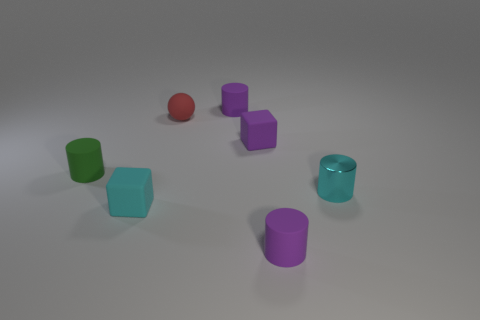Subtract all purple cylinders. How many were subtracted if there are1purple cylinders left? 1 Add 1 tiny cyan rubber things. How many objects exist? 8 Subtract all blocks. How many objects are left? 5 Subtract 0 blue cylinders. How many objects are left? 7 Subtract all tiny green objects. Subtract all green things. How many objects are left? 5 Add 7 purple matte cylinders. How many purple matte cylinders are left? 9 Add 2 large blue metallic cylinders. How many large blue metallic cylinders exist? 2 